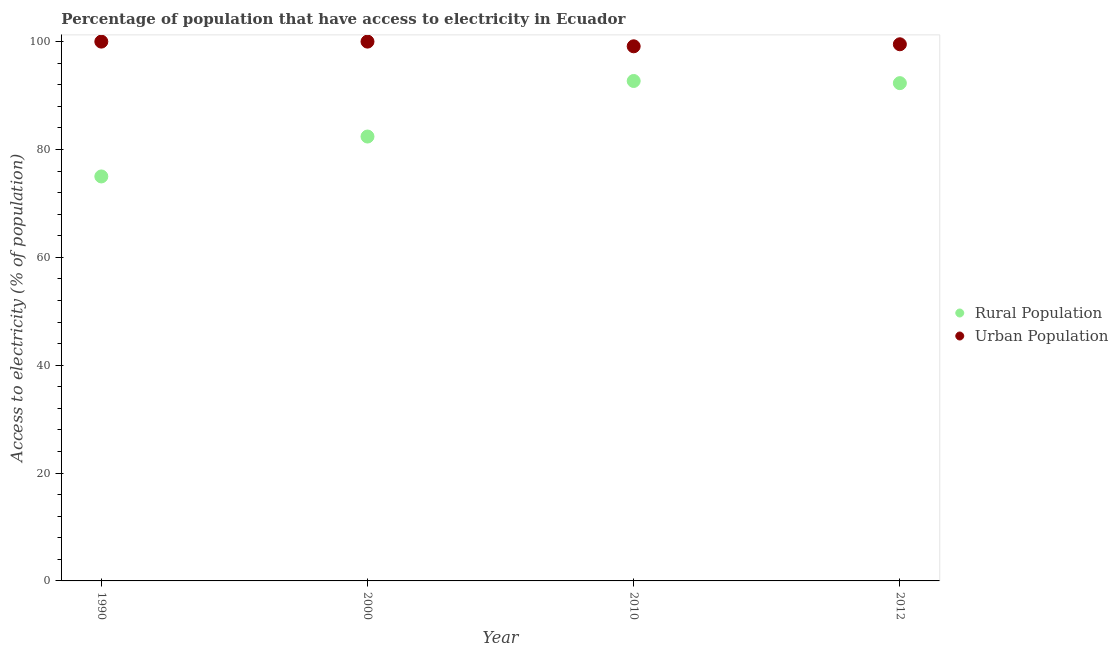How many different coloured dotlines are there?
Provide a short and direct response. 2. Across all years, what is the maximum percentage of rural population having access to electricity?
Offer a terse response. 92.7. Across all years, what is the minimum percentage of rural population having access to electricity?
Offer a terse response. 75. In which year was the percentage of urban population having access to electricity maximum?
Provide a succinct answer. 1990. What is the total percentage of rural population having access to electricity in the graph?
Your response must be concise. 342.4. What is the difference between the percentage of urban population having access to electricity in 2000 and that in 2010?
Offer a terse response. 0.87. What is the difference between the percentage of urban population having access to electricity in 1990 and the percentage of rural population having access to electricity in 2012?
Your answer should be very brief. 7.7. What is the average percentage of urban population having access to electricity per year?
Your answer should be very brief. 99.66. In how many years, is the percentage of urban population having access to electricity greater than 64 %?
Provide a succinct answer. 4. What is the ratio of the percentage of rural population having access to electricity in 1990 to that in 2012?
Offer a very short reply. 0.81. Is the percentage of rural population having access to electricity in 2000 less than that in 2012?
Your response must be concise. Yes. What is the difference between the highest and the second highest percentage of rural population having access to electricity?
Provide a succinct answer. 0.4. What is the difference between the highest and the lowest percentage of rural population having access to electricity?
Offer a very short reply. 17.7. Is the sum of the percentage of rural population having access to electricity in 1990 and 2012 greater than the maximum percentage of urban population having access to electricity across all years?
Offer a very short reply. Yes. Does the percentage of rural population having access to electricity monotonically increase over the years?
Your answer should be very brief. No. Is the percentage of rural population having access to electricity strictly less than the percentage of urban population having access to electricity over the years?
Give a very brief answer. Yes. What is the difference between two consecutive major ticks on the Y-axis?
Offer a terse response. 20. Are the values on the major ticks of Y-axis written in scientific E-notation?
Provide a short and direct response. No. Does the graph contain any zero values?
Offer a terse response. No. Does the graph contain grids?
Make the answer very short. No. Where does the legend appear in the graph?
Keep it short and to the point. Center right. What is the title of the graph?
Make the answer very short. Percentage of population that have access to electricity in Ecuador. What is the label or title of the X-axis?
Keep it short and to the point. Year. What is the label or title of the Y-axis?
Ensure brevity in your answer.  Access to electricity (% of population). What is the Access to electricity (% of population) in Urban Population in 1990?
Give a very brief answer. 100. What is the Access to electricity (% of population) in Rural Population in 2000?
Provide a short and direct response. 82.4. What is the Access to electricity (% of population) of Urban Population in 2000?
Your answer should be compact. 100. What is the Access to electricity (% of population) in Rural Population in 2010?
Give a very brief answer. 92.7. What is the Access to electricity (% of population) in Urban Population in 2010?
Give a very brief answer. 99.13. What is the Access to electricity (% of population) of Rural Population in 2012?
Your answer should be compact. 92.3. What is the Access to electricity (% of population) in Urban Population in 2012?
Offer a very short reply. 99.51. Across all years, what is the maximum Access to electricity (% of population) in Rural Population?
Your answer should be compact. 92.7. Across all years, what is the maximum Access to electricity (% of population) of Urban Population?
Offer a terse response. 100. Across all years, what is the minimum Access to electricity (% of population) in Rural Population?
Your answer should be compact. 75. Across all years, what is the minimum Access to electricity (% of population) in Urban Population?
Your answer should be compact. 99.13. What is the total Access to electricity (% of population) in Rural Population in the graph?
Provide a succinct answer. 342.4. What is the total Access to electricity (% of population) in Urban Population in the graph?
Your answer should be compact. 398.64. What is the difference between the Access to electricity (% of population) in Rural Population in 1990 and that in 2000?
Give a very brief answer. -7.4. What is the difference between the Access to electricity (% of population) of Urban Population in 1990 and that in 2000?
Keep it short and to the point. 0. What is the difference between the Access to electricity (% of population) in Rural Population in 1990 and that in 2010?
Provide a succinct answer. -17.7. What is the difference between the Access to electricity (% of population) of Urban Population in 1990 and that in 2010?
Your answer should be very brief. 0.87. What is the difference between the Access to electricity (% of population) in Rural Population in 1990 and that in 2012?
Offer a terse response. -17.3. What is the difference between the Access to electricity (% of population) in Urban Population in 1990 and that in 2012?
Your answer should be compact. 0.49. What is the difference between the Access to electricity (% of population) in Urban Population in 2000 and that in 2010?
Keep it short and to the point. 0.87. What is the difference between the Access to electricity (% of population) in Urban Population in 2000 and that in 2012?
Ensure brevity in your answer.  0.49. What is the difference between the Access to electricity (% of population) in Rural Population in 2010 and that in 2012?
Your answer should be very brief. 0.4. What is the difference between the Access to electricity (% of population) in Urban Population in 2010 and that in 2012?
Ensure brevity in your answer.  -0.38. What is the difference between the Access to electricity (% of population) of Rural Population in 1990 and the Access to electricity (% of population) of Urban Population in 2000?
Make the answer very short. -25. What is the difference between the Access to electricity (% of population) in Rural Population in 1990 and the Access to electricity (% of population) in Urban Population in 2010?
Provide a short and direct response. -24.13. What is the difference between the Access to electricity (% of population) in Rural Population in 1990 and the Access to electricity (% of population) in Urban Population in 2012?
Provide a short and direct response. -24.51. What is the difference between the Access to electricity (% of population) in Rural Population in 2000 and the Access to electricity (% of population) in Urban Population in 2010?
Your response must be concise. -16.73. What is the difference between the Access to electricity (% of population) of Rural Population in 2000 and the Access to electricity (% of population) of Urban Population in 2012?
Make the answer very short. -17.11. What is the difference between the Access to electricity (% of population) in Rural Population in 2010 and the Access to electricity (% of population) in Urban Population in 2012?
Make the answer very short. -6.81. What is the average Access to electricity (% of population) in Rural Population per year?
Ensure brevity in your answer.  85.6. What is the average Access to electricity (% of population) of Urban Population per year?
Your response must be concise. 99.66. In the year 2000, what is the difference between the Access to electricity (% of population) in Rural Population and Access to electricity (% of population) in Urban Population?
Keep it short and to the point. -17.6. In the year 2010, what is the difference between the Access to electricity (% of population) of Rural Population and Access to electricity (% of population) of Urban Population?
Your answer should be very brief. -6.43. In the year 2012, what is the difference between the Access to electricity (% of population) of Rural Population and Access to electricity (% of population) of Urban Population?
Make the answer very short. -7.21. What is the ratio of the Access to electricity (% of population) in Rural Population in 1990 to that in 2000?
Make the answer very short. 0.91. What is the ratio of the Access to electricity (% of population) in Rural Population in 1990 to that in 2010?
Give a very brief answer. 0.81. What is the ratio of the Access to electricity (% of population) in Urban Population in 1990 to that in 2010?
Your answer should be compact. 1.01. What is the ratio of the Access to electricity (% of population) of Rural Population in 1990 to that in 2012?
Offer a very short reply. 0.81. What is the ratio of the Access to electricity (% of population) of Rural Population in 2000 to that in 2010?
Give a very brief answer. 0.89. What is the ratio of the Access to electricity (% of population) of Urban Population in 2000 to that in 2010?
Ensure brevity in your answer.  1.01. What is the ratio of the Access to electricity (% of population) in Rural Population in 2000 to that in 2012?
Keep it short and to the point. 0.89. What is the ratio of the Access to electricity (% of population) of Urban Population in 2010 to that in 2012?
Give a very brief answer. 1. What is the difference between the highest and the lowest Access to electricity (% of population) of Rural Population?
Provide a succinct answer. 17.7. What is the difference between the highest and the lowest Access to electricity (% of population) of Urban Population?
Offer a very short reply. 0.87. 